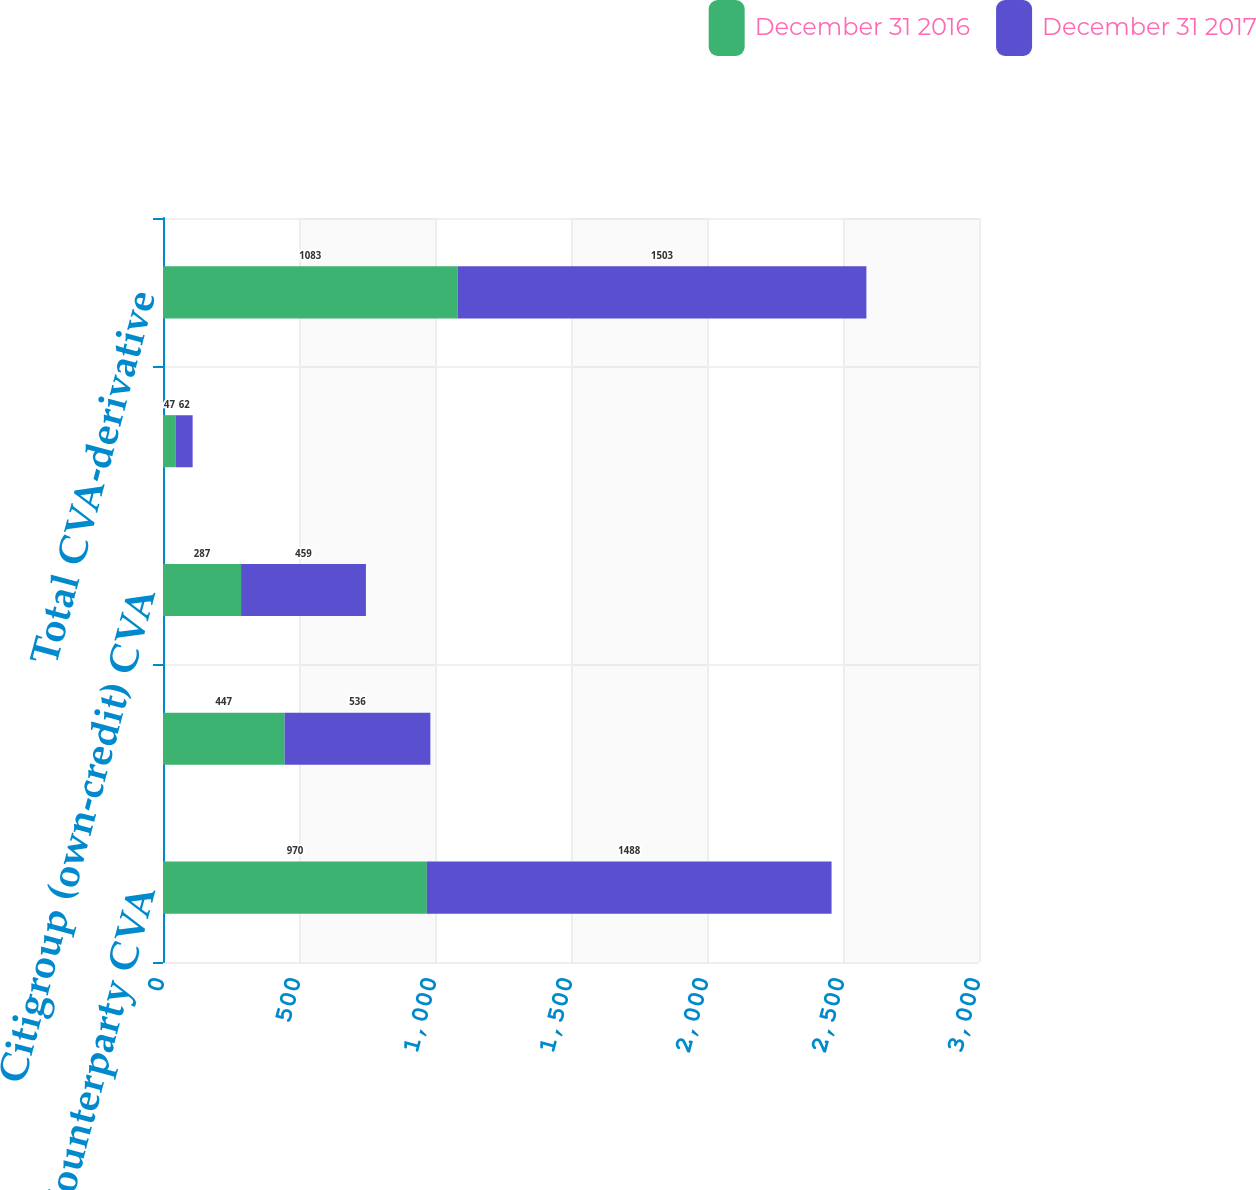Convert chart to OTSL. <chart><loc_0><loc_0><loc_500><loc_500><stacked_bar_chart><ecel><fcel>Counterparty CVA<fcel>Asset FVA<fcel>Citigroup (own-credit) CVA<fcel>Liability FVA<fcel>Total CVA-derivative<nl><fcel>December 31 2016<fcel>970<fcel>447<fcel>287<fcel>47<fcel>1083<nl><fcel>December 31 2017<fcel>1488<fcel>536<fcel>459<fcel>62<fcel>1503<nl></chart> 